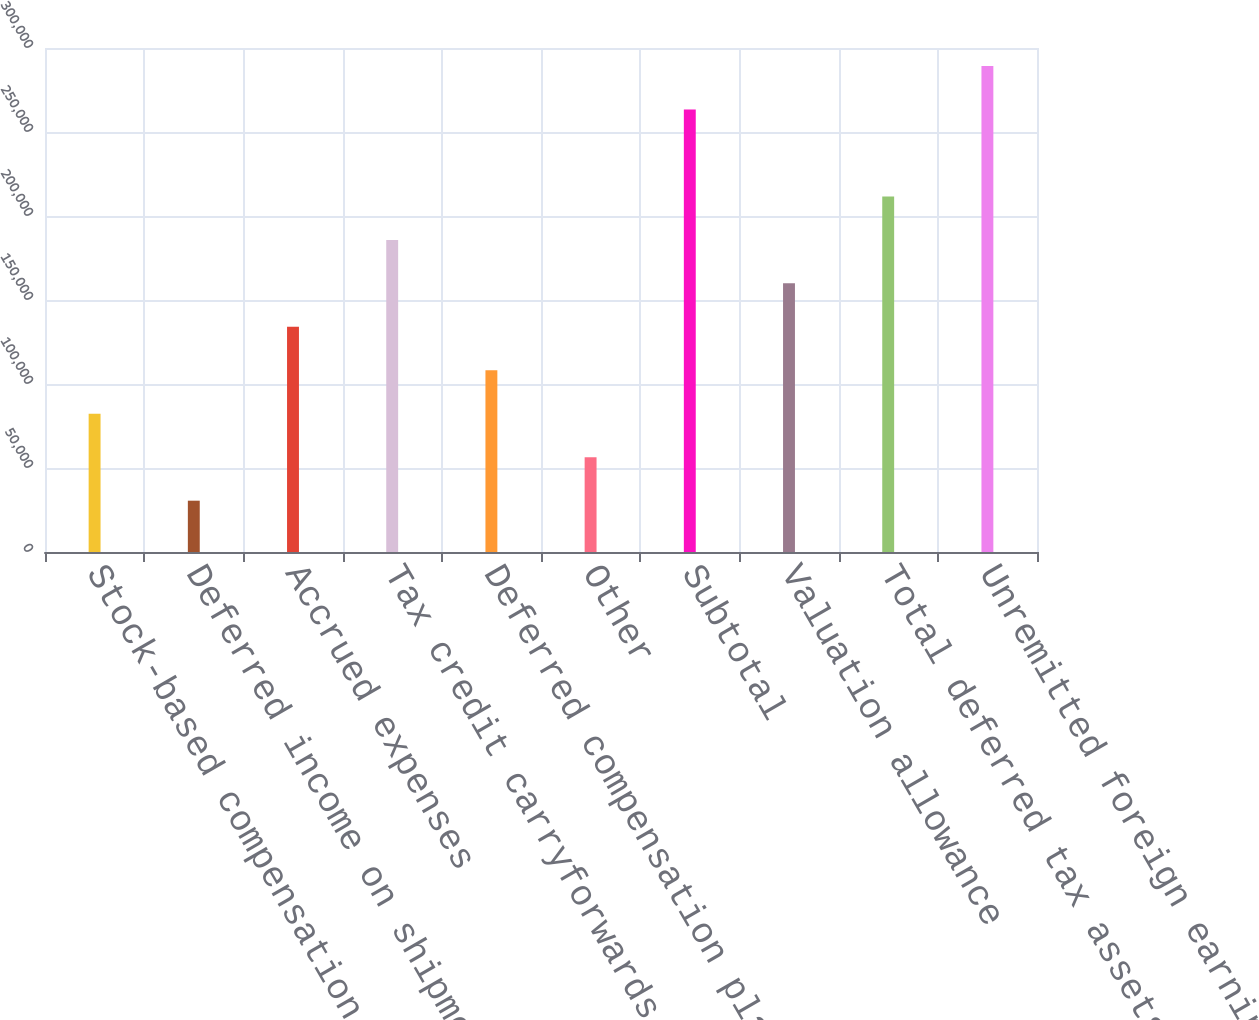Convert chart. <chart><loc_0><loc_0><loc_500><loc_500><bar_chart><fcel>Stock-based compensation<fcel>Deferred income on shipments<fcel>Accrued expenses<fcel>Tax credit carryforwards<fcel>Deferred compensation plan<fcel>Other<fcel>Subtotal<fcel>Valuation allowance<fcel>Total deferred tax assets<fcel>Unremitted foreign earnings<nl><fcel>82287.2<fcel>30542.4<fcel>134032<fcel>185777<fcel>108160<fcel>56414.8<fcel>263394<fcel>159904<fcel>211649<fcel>289266<nl></chart> 